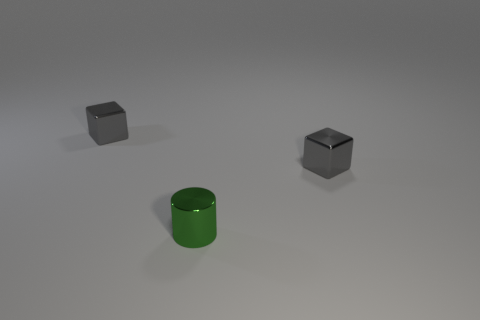Add 3 metal cylinders. How many objects exist? 6 Subtract all brown blocks. Subtract all gray cylinders. How many blocks are left? 2 Subtract all yellow cubes. How many red cylinders are left? 0 Subtract all tiny objects. Subtract all gray spheres. How many objects are left? 0 Add 1 small gray metal things. How many small gray metal things are left? 3 Add 3 tiny blocks. How many tiny blocks exist? 5 Subtract 0 brown cubes. How many objects are left? 3 Subtract all cylinders. How many objects are left? 2 Subtract 1 cylinders. How many cylinders are left? 0 